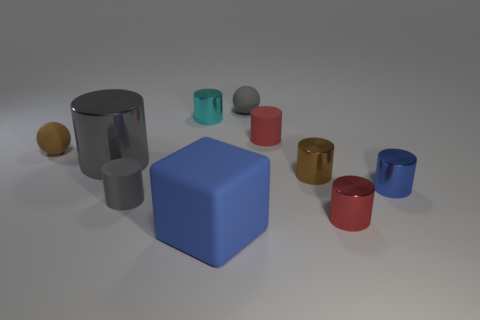Subtract all brown cylinders. How many cylinders are left? 6 Subtract all gray matte cylinders. How many cylinders are left? 6 Subtract all brown cylinders. Subtract all red balls. How many cylinders are left? 6 Subtract all cubes. How many objects are left? 9 Subtract all big purple rubber cubes. Subtract all small matte balls. How many objects are left? 8 Add 7 red cylinders. How many red cylinders are left? 9 Add 2 small blue cylinders. How many small blue cylinders exist? 3 Subtract 0 purple spheres. How many objects are left? 10 